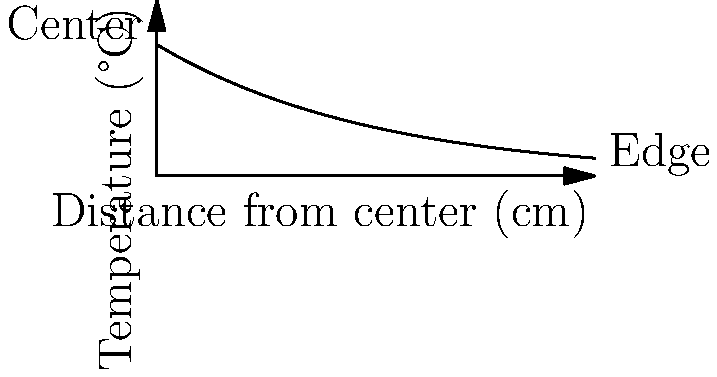When cooking with a frying pan, you notice that the center is hotter than the edges. The graph shows the temperature distribution across the pan from center to edge. If you're cooking eggs, where should you crack them for faster cooking, and why? To understand where to crack the eggs for faster cooking, let's analyze the temperature distribution:

1. The graph shows temperature (y-axis) vs. distance from the center (x-axis).
2. At the center (x = 0), the temperature is highest, around 3°C above the baseline.
3. As we move towards the edge (x increases), the temperature decreases exponentially.
4. The curve follows the equation $T = 3e^{-x/5}$, where T is temperature and x is distance.
5. Higher temperature leads to faster cooking.
6. Therefore, cracking the eggs closer to the center will result in faster cooking due to higher temperature.

The center of the pan is the hottest because it's directly above the heat source. Heat spreads outward from the center, losing energy as it travels, resulting in cooler edges.
Answer: Center, for higher temperature. 